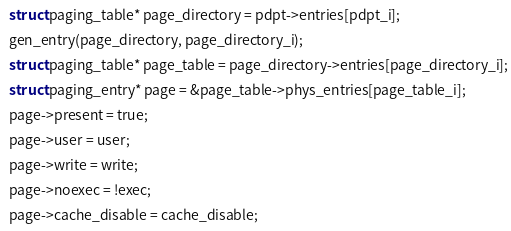<code> <loc_0><loc_0><loc_500><loc_500><_C_>  struct paging_table* page_directory = pdpt->entries[pdpt_i];
  gen_entry(page_directory, page_directory_i);
  struct paging_table* page_table = page_directory->entries[page_directory_i];
  struct paging_entry* page = &page_table->phys_entries[page_table_i];
  page->present = true;
  page->user = user;
  page->write = write;
  page->noexec = !exec;
  page->cache_disable = cache_disable;</code> 